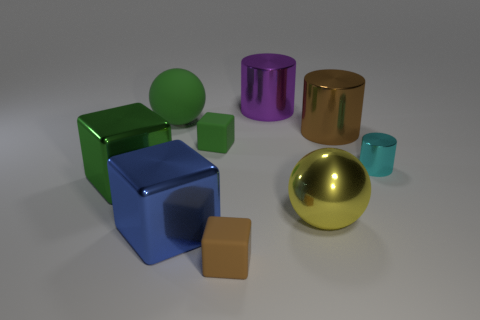What shape is the green object that is the same size as the brown block?
Provide a succinct answer. Cube. Is the size of the matte block in front of the yellow thing the same as the green rubber ball?
Your answer should be very brief. No. There is a green sphere that is the same size as the purple metal cylinder; what is it made of?
Ensure brevity in your answer.  Rubber. There is a large ball on the left side of the brown thing in front of the blue object; is there a block that is to the left of it?
Provide a short and direct response. Yes. Is there any other thing that is the same shape as the large purple thing?
Provide a short and direct response. Yes. There is a matte thing that is left of the blue metallic object; is its color the same as the small cube behind the tiny metallic cylinder?
Your answer should be very brief. Yes. Are any red shiny balls visible?
Your answer should be very brief. No. There is a large cube that is the same color as the rubber sphere; what material is it?
Your response must be concise. Metal. There is a metallic cylinder in front of the brown cylinder right of the matte cube behind the yellow sphere; what is its size?
Provide a short and direct response. Small. There is a cyan metallic thing; is it the same shape as the small rubber thing that is behind the tiny cyan object?
Make the answer very short. No. 